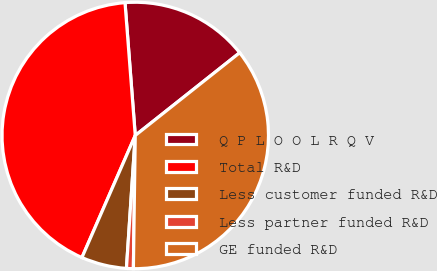<chart> <loc_0><loc_0><loc_500><loc_500><pie_chart><fcel>Q P L O O L R Q V<fcel>Total R&D<fcel>Less customer funded R&D<fcel>Less partner funded R&D<fcel>GE funded R&D<nl><fcel>15.56%<fcel>42.22%<fcel>5.5%<fcel>0.83%<fcel>35.89%<nl></chart> 